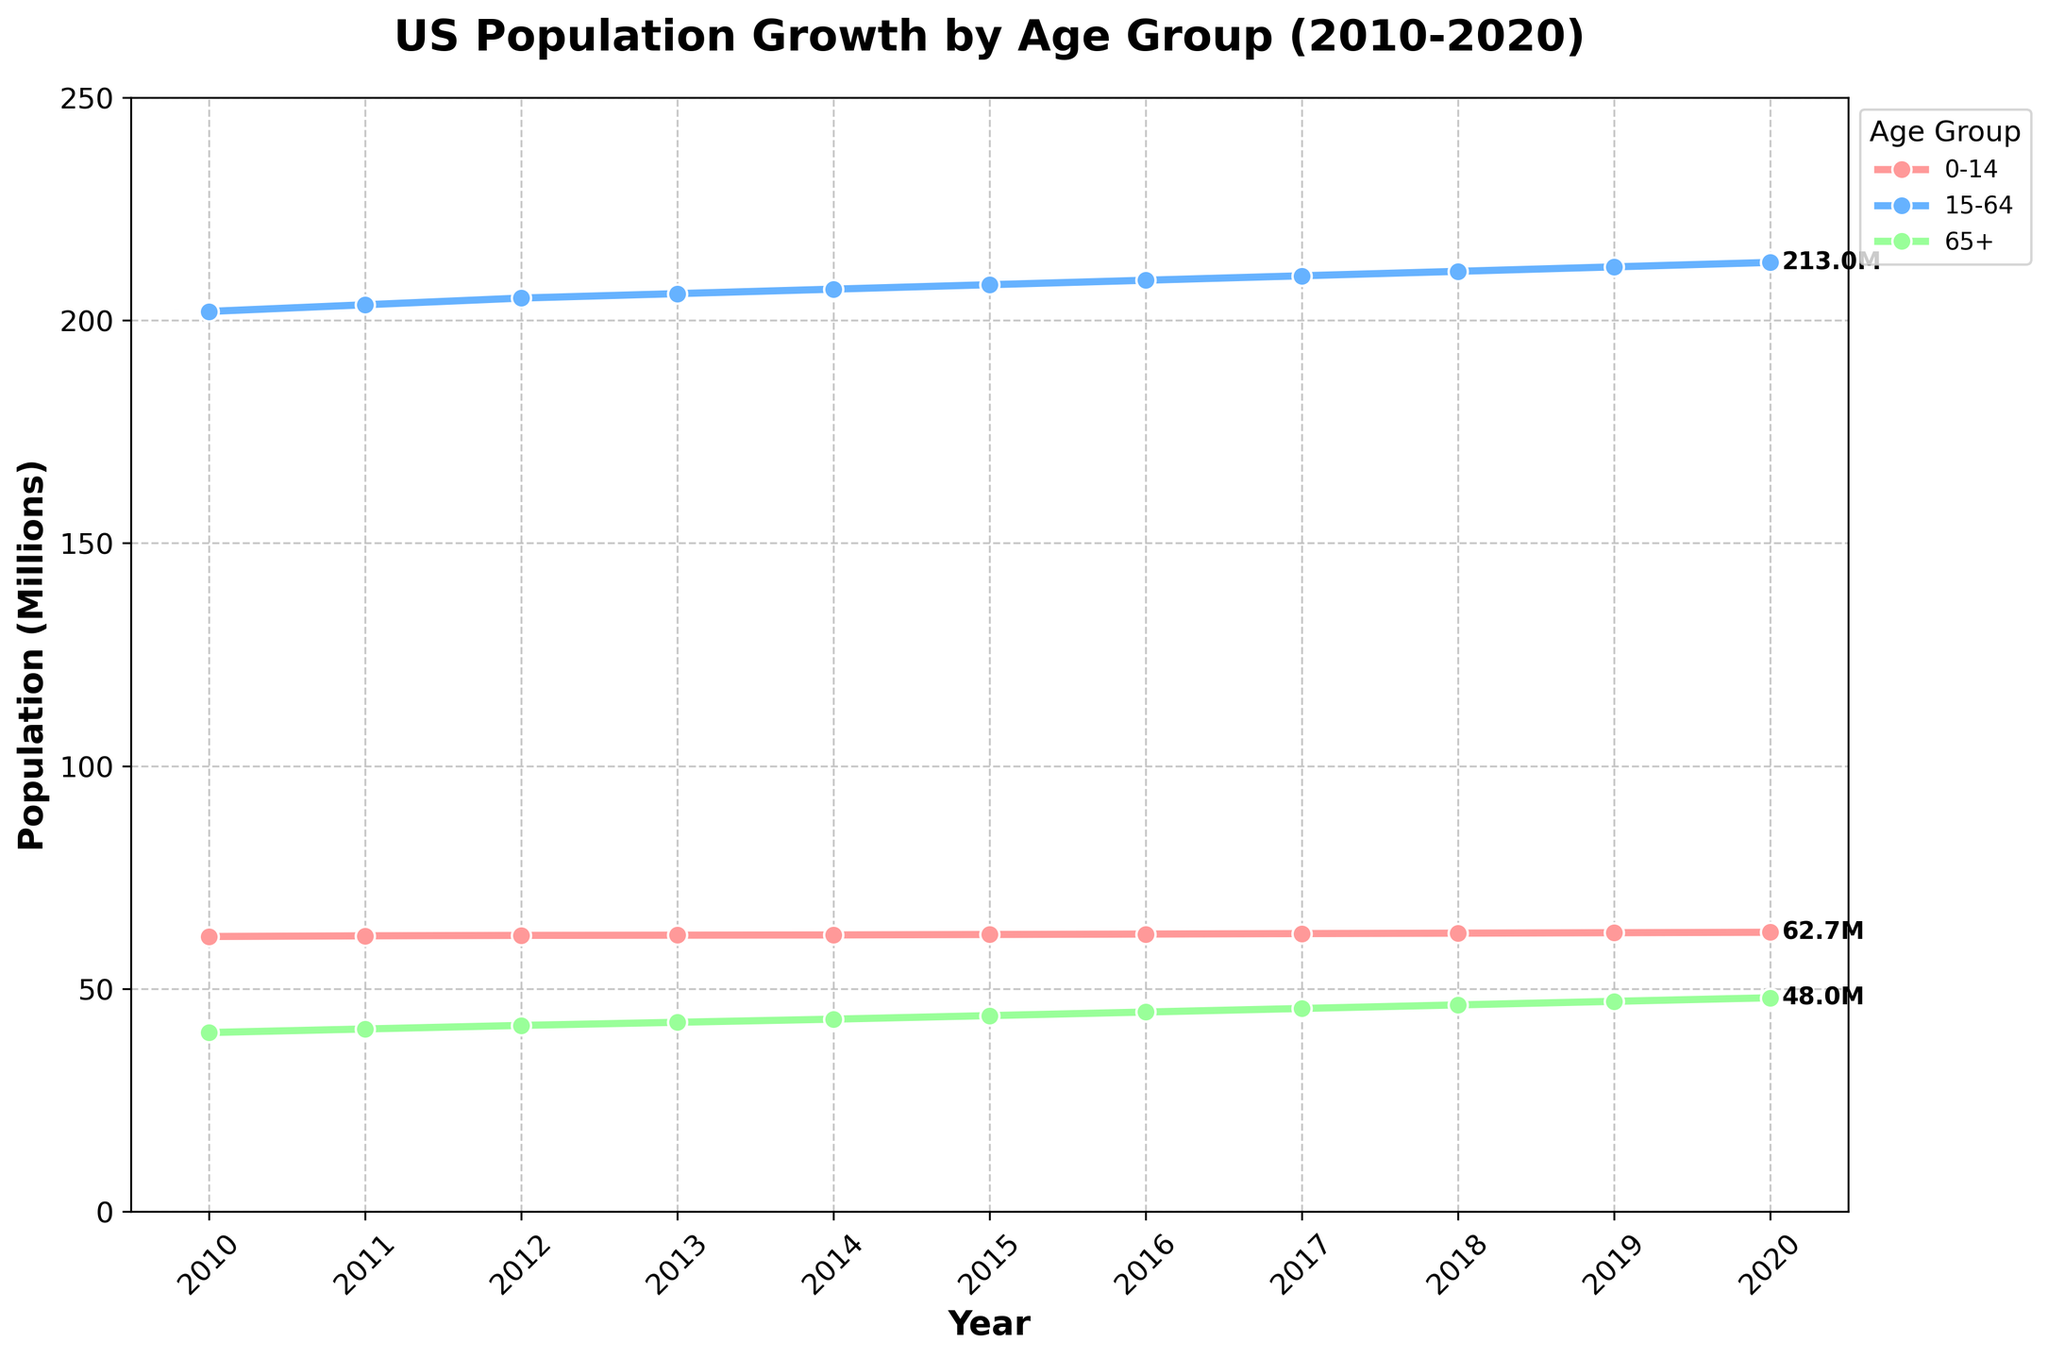What is the title of the plot? The title of the plot is located at the top, above the chart and reads as 'US Population Growth by Age Group (2010-2020)'
Answer: US Population Growth by Age Group (2010-2020) How many age groups are depicted in the chart? There are three distinct lines, each labeled for a specific age group, and this information can be seen in the legend on the plot's right side.
Answer: Three Which age group had the highest population in 2010? By looking at the plot's starting point (the year 2010), it is evident that the 15-64 age group starts at the highest point compared to the other two age groups.
Answer: 15-64 How did the population of the 65+ age group change from 2010 to 2020? The population of the 65+ age group starts at 40.2 million in 2010 and ends at 48 million in 2020. The change is therefore 48 - 40.2 = 7.8 million.
Answer: Increased by 7.8 million Which year saw the largest increase in the population for the 0-14 age group? By examining the slope of the lines for the 0-14 age group, we can see the largest vertical leap between years. In 2011, the population increases from 61.75 to 61.9 million, which is a 1.25 million increase.
Answer: 2011 What is the total population across all age groups in 2015? The population values for 2015 are 62.2 million (0-14), 208 million (15-64), and 44 million (65+). Summing these numbers gives 62.2 + 208 + 44 = 314.2 million.
Answer: 314.2 million Which age group experienced the most significant relative increase in their population over the period? By calculating the percentage increase for each age group: (48-40.2)/40.2 for 65+, (627-617.5)/617.5 for 0-14, and (213-202)/202 for 15-64, we find that the 65+ age group has the highest increase of roughly 19.4%.
Answer: 65+ Is there any year where the population trend for any age group decreased? By closely examining the curves, all age group's populations appear to increase steadily each year as none of the lines dip.
Answer: No Comparable to the previous year, which age group had the smallest increase in 2020? The 0-14 age group had an increase from 62.6 to 62.7 million (0.1 million increase), the 15-64 age group had an increase from 212 to 213 million (1 million increase) and the 65+ saw from 47.2 to 48 million (0.8 million increase).
Answer: 0-14 